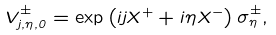<formula> <loc_0><loc_0><loc_500><loc_500>V ^ { \pm } _ { j , \eta , 0 } = \exp \left ( i j X ^ { + } + i \eta X ^ { - } \right ) \sigma ^ { \pm } _ { \eta } ,</formula> 